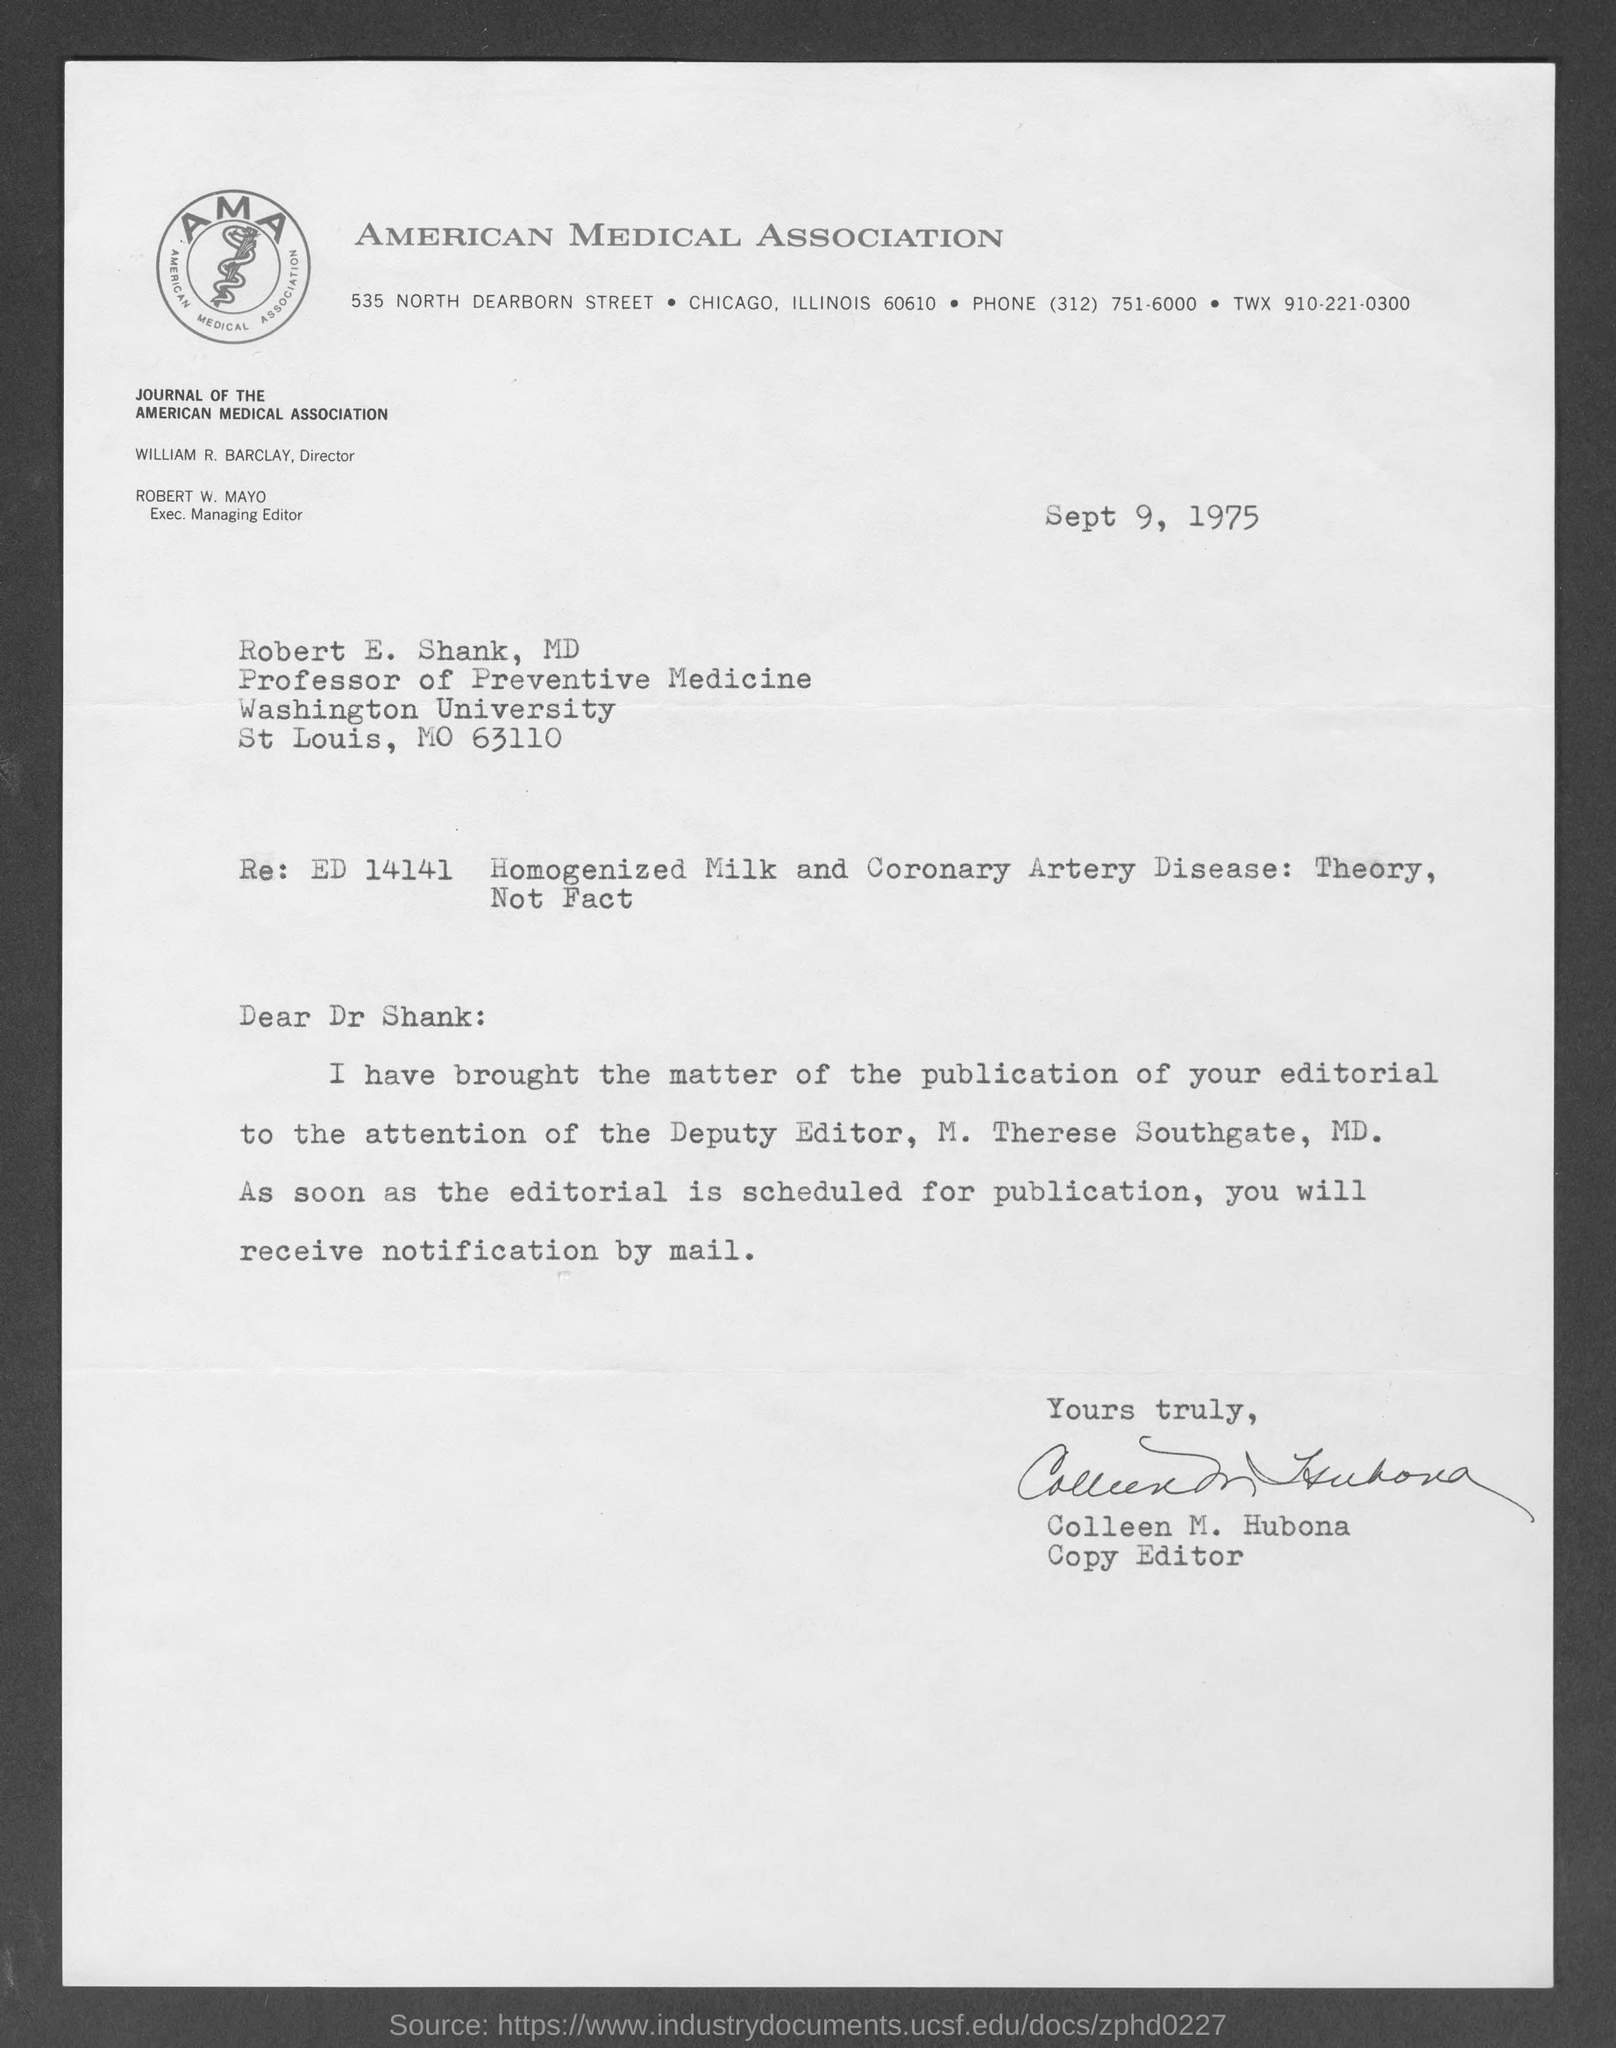Which association is mentioned in the letterhead?
Your answer should be compact. American Medical Association. Who is the Director of the Journal of the American Medical Association?
Make the answer very short. WILLIAM R. BARCLAY. What is the designation of ROBERT W. MAYO?
Offer a terse response. Exec. Managing Editor. What is the date mentioned in this letter?
Give a very brief answer. Sept 9, 1975. What is the designation of Colleen M. Hubona?
Offer a very short reply. Copy Editor. Who has signed the document?
Offer a very short reply. Colleen M. Hubona. What is the designation of M. Therese Southgate, MD.?
Make the answer very short. Deputy Editor. 